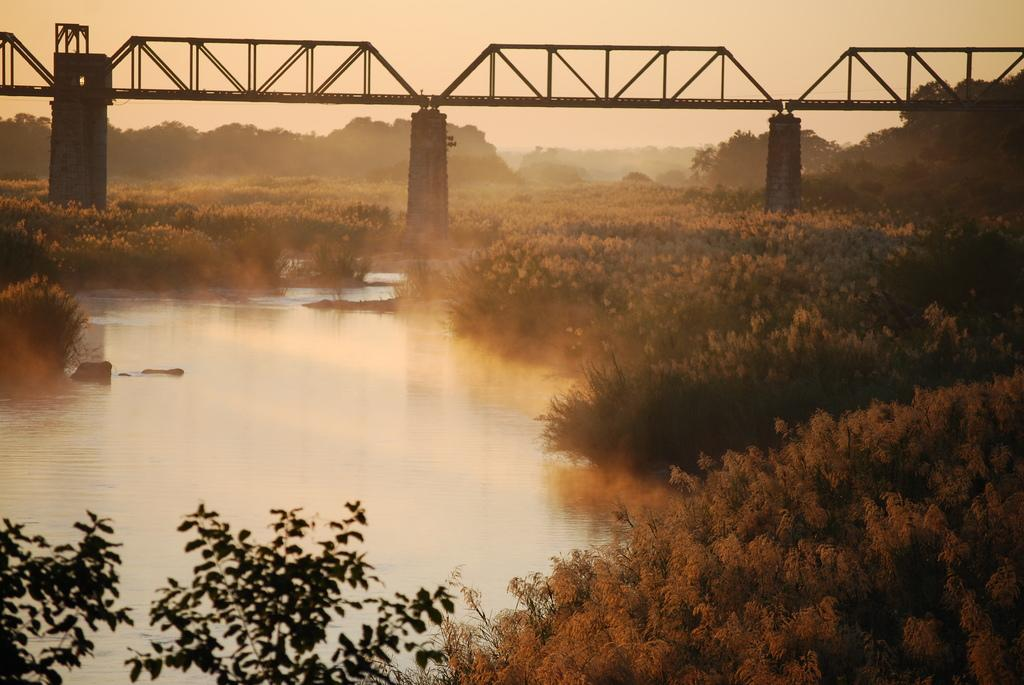What natural element is visible in the image? Water is visible in the image. What type of vegetation can be seen in the image? Plants and trees are visible in the image. What man-made structure is present in the image? There is a bridge in the image. What type of breakfast is being served on the bridge in the image? There is no breakfast or any indication of food in the image. What type of soap is being used to clean the plants in the image? There is no soap or any indication of cleaning in the image. 